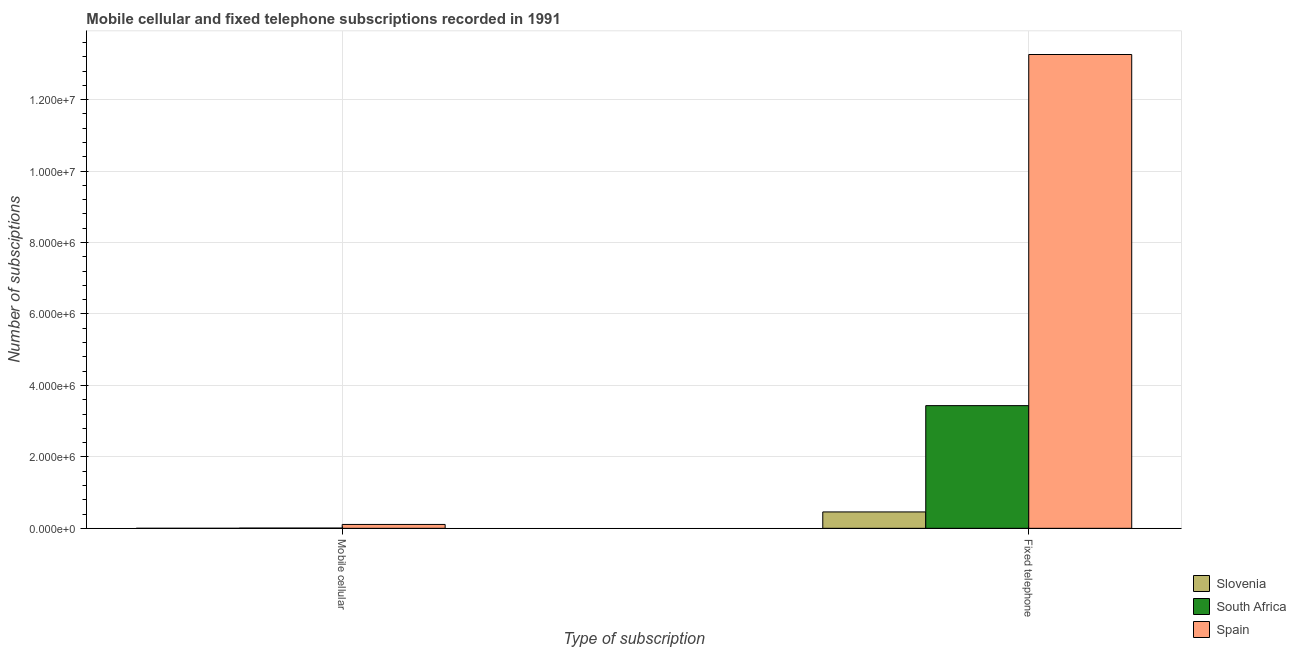Are the number of bars per tick equal to the number of legend labels?
Ensure brevity in your answer.  Yes. How many bars are there on the 2nd tick from the right?
Offer a very short reply. 3. What is the label of the 1st group of bars from the left?
Offer a very short reply. Mobile cellular. What is the number of mobile cellular subscriptions in Spain?
Your answer should be compact. 1.08e+05. Across all countries, what is the maximum number of mobile cellular subscriptions?
Your answer should be very brief. 1.08e+05. Across all countries, what is the minimum number of fixed telephone subscriptions?
Keep it short and to the point. 4.59e+05. In which country was the number of fixed telephone subscriptions maximum?
Your response must be concise. Spain. In which country was the number of mobile cellular subscriptions minimum?
Your response must be concise. Slovenia. What is the total number of fixed telephone subscriptions in the graph?
Make the answer very short. 1.72e+07. What is the difference between the number of mobile cellular subscriptions in Slovenia and that in South Africa?
Offer a terse response. -6577. What is the difference between the number of mobile cellular subscriptions in Spain and the number of fixed telephone subscriptions in South Africa?
Your response must be concise. -3.33e+06. What is the average number of mobile cellular subscriptions per country?
Your answer should be compact. 3.87e+04. What is the difference between the number of fixed telephone subscriptions and number of mobile cellular subscriptions in Slovenia?
Keep it short and to the point. 4.58e+05. In how many countries, is the number of mobile cellular subscriptions greater than 10400000 ?
Make the answer very short. 0. What is the ratio of the number of fixed telephone subscriptions in South Africa to that in Spain?
Your response must be concise. 0.26. Is the number of fixed telephone subscriptions in Spain less than that in Slovenia?
Keep it short and to the point. No. In how many countries, is the number of fixed telephone subscriptions greater than the average number of fixed telephone subscriptions taken over all countries?
Keep it short and to the point. 1. What does the 3rd bar from the left in Mobile cellular represents?
Offer a very short reply. Spain. How many bars are there?
Provide a succinct answer. 6. Are all the bars in the graph horizontal?
Offer a terse response. No. How many countries are there in the graph?
Your answer should be very brief. 3. What is the difference between two consecutive major ticks on the Y-axis?
Offer a terse response. 2.00e+06. Are the values on the major ticks of Y-axis written in scientific E-notation?
Offer a terse response. Yes. Does the graph contain any zero values?
Your answer should be very brief. No. Where does the legend appear in the graph?
Ensure brevity in your answer.  Bottom right. How many legend labels are there?
Your answer should be very brief. 3. How are the legend labels stacked?
Your response must be concise. Vertical. What is the title of the graph?
Ensure brevity in your answer.  Mobile cellular and fixed telephone subscriptions recorded in 1991. Does "Afghanistan" appear as one of the legend labels in the graph?
Provide a short and direct response. No. What is the label or title of the X-axis?
Keep it short and to the point. Type of subscription. What is the label or title of the Y-axis?
Your answer should be very brief. Number of subsciptions. What is the Number of subsciptions of Slovenia in Mobile cellular?
Your answer should be compact. 523. What is the Number of subsciptions of South Africa in Mobile cellular?
Your answer should be very brief. 7100. What is the Number of subsciptions in Spain in Mobile cellular?
Your answer should be very brief. 1.08e+05. What is the Number of subsciptions in Slovenia in Fixed telephone?
Give a very brief answer. 4.59e+05. What is the Number of subsciptions of South Africa in Fixed telephone?
Your response must be concise. 3.43e+06. What is the Number of subsciptions in Spain in Fixed telephone?
Keep it short and to the point. 1.33e+07. Across all Type of subscription, what is the maximum Number of subsciptions of Slovenia?
Ensure brevity in your answer.  4.59e+05. Across all Type of subscription, what is the maximum Number of subsciptions in South Africa?
Offer a terse response. 3.43e+06. Across all Type of subscription, what is the maximum Number of subsciptions of Spain?
Offer a very short reply. 1.33e+07. Across all Type of subscription, what is the minimum Number of subsciptions in Slovenia?
Make the answer very short. 523. Across all Type of subscription, what is the minimum Number of subsciptions in South Africa?
Your answer should be very brief. 7100. Across all Type of subscription, what is the minimum Number of subsciptions of Spain?
Offer a very short reply. 1.08e+05. What is the total Number of subsciptions in Slovenia in the graph?
Your answer should be compact. 4.59e+05. What is the total Number of subsciptions in South Africa in the graph?
Provide a short and direct response. 3.44e+06. What is the total Number of subsciptions in Spain in the graph?
Give a very brief answer. 1.34e+07. What is the difference between the Number of subsciptions of Slovenia in Mobile cellular and that in Fixed telephone?
Keep it short and to the point. -4.58e+05. What is the difference between the Number of subsciptions in South Africa in Mobile cellular and that in Fixed telephone?
Provide a short and direct response. -3.43e+06. What is the difference between the Number of subsciptions in Spain in Mobile cellular and that in Fixed telephone?
Provide a short and direct response. -1.32e+07. What is the difference between the Number of subsciptions in Slovenia in Mobile cellular and the Number of subsciptions in South Africa in Fixed telephone?
Provide a succinct answer. -3.43e+06. What is the difference between the Number of subsciptions in Slovenia in Mobile cellular and the Number of subsciptions in Spain in Fixed telephone?
Make the answer very short. -1.33e+07. What is the difference between the Number of subsciptions of South Africa in Mobile cellular and the Number of subsciptions of Spain in Fixed telephone?
Your answer should be compact. -1.33e+07. What is the average Number of subsciptions of Slovenia per Type of subscription?
Make the answer very short. 2.30e+05. What is the average Number of subsciptions in South Africa per Type of subscription?
Keep it short and to the point. 1.72e+06. What is the average Number of subsciptions of Spain per Type of subscription?
Give a very brief answer. 6.69e+06. What is the difference between the Number of subsciptions in Slovenia and Number of subsciptions in South Africa in Mobile cellular?
Your answer should be very brief. -6577. What is the difference between the Number of subsciptions in Slovenia and Number of subsciptions in Spain in Mobile cellular?
Provide a short and direct response. -1.08e+05. What is the difference between the Number of subsciptions in South Africa and Number of subsciptions in Spain in Mobile cellular?
Ensure brevity in your answer.  -1.01e+05. What is the difference between the Number of subsciptions in Slovenia and Number of subsciptions in South Africa in Fixed telephone?
Your response must be concise. -2.98e+06. What is the difference between the Number of subsciptions in Slovenia and Number of subsciptions in Spain in Fixed telephone?
Provide a succinct answer. -1.28e+07. What is the difference between the Number of subsciptions of South Africa and Number of subsciptions of Spain in Fixed telephone?
Ensure brevity in your answer.  -9.83e+06. What is the ratio of the Number of subsciptions of Slovenia in Mobile cellular to that in Fixed telephone?
Keep it short and to the point. 0. What is the ratio of the Number of subsciptions in South Africa in Mobile cellular to that in Fixed telephone?
Your answer should be very brief. 0. What is the ratio of the Number of subsciptions of Spain in Mobile cellular to that in Fixed telephone?
Make the answer very short. 0.01. What is the difference between the highest and the second highest Number of subsciptions of Slovenia?
Offer a very short reply. 4.58e+05. What is the difference between the highest and the second highest Number of subsciptions in South Africa?
Offer a terse response. 3.43e+06. What is the difference between the highest and the second highest Number of subsciptions in Spain?
Your answer should be very brief. 1.32e+07. What is the difference between the highest and the lowest Number of subsciptions in Slovenia?
Your answer should be compact. 4.58e+05. What is the difference between the highest and the lowest Number of subsciptions in South Africa?
Your response must be concise. 3.43e+06. What is the difference between the highest and the lowest Number of subsciptions of Spain?
Give a very brief answer. 1.32e+07. 